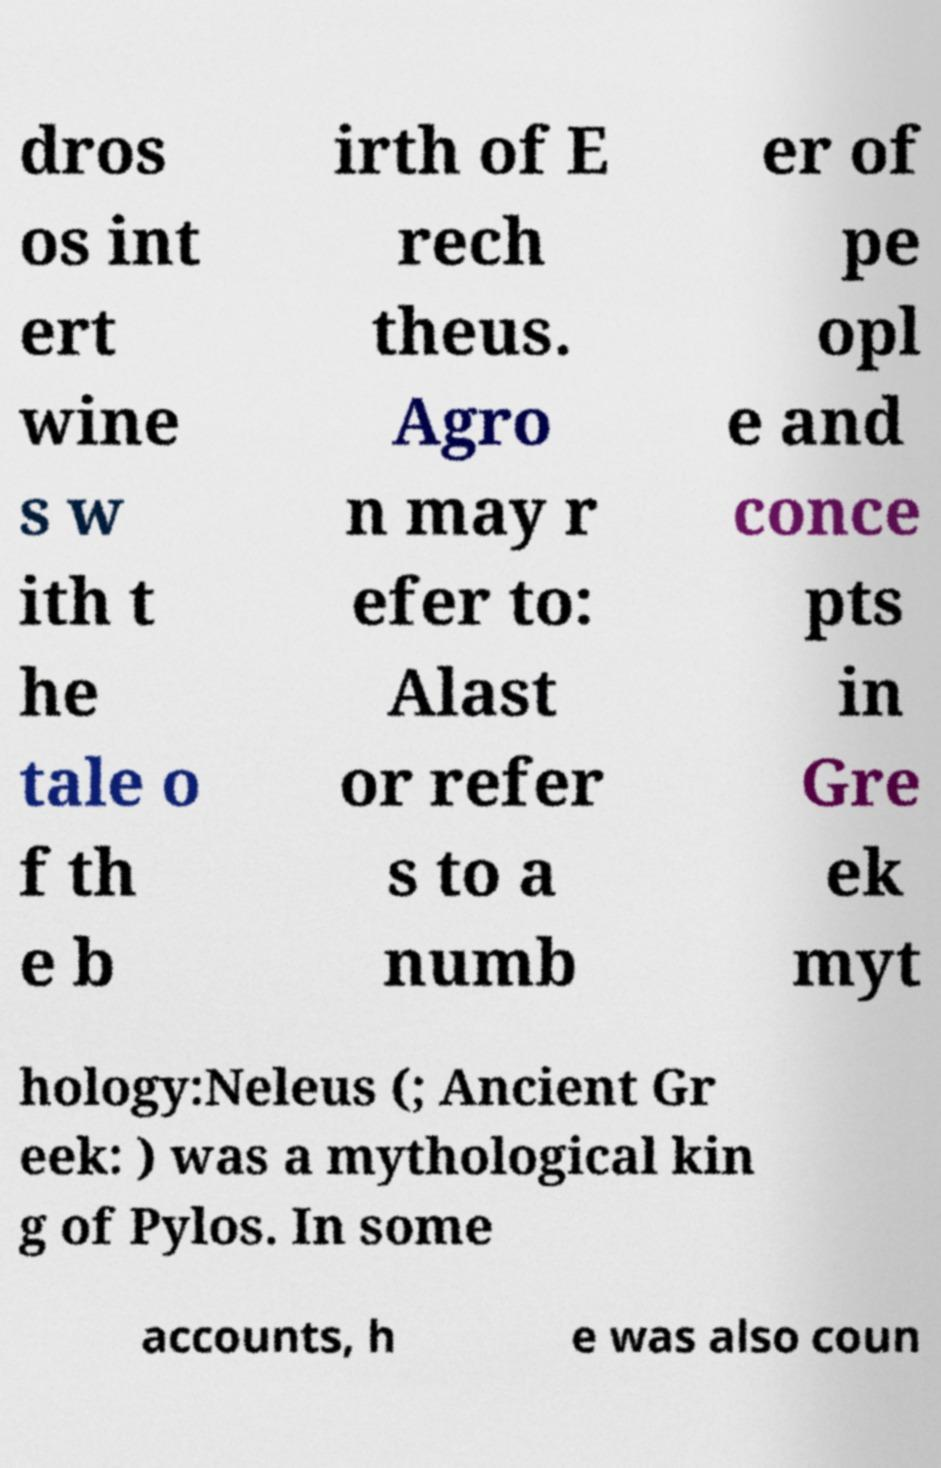Please identify and transcribe the text found in this image. dros os int ert wine s w ith t he tale o f th e b irth of E rech theus. Agro n may r efer to: Alast or refer s to a numb er of pe opl e and conce pts in Gre ek myt hology:Neleus (; Ancient Gr eek: ) was a mythological kin g of Pylos. In some accounts, h e was also coun 